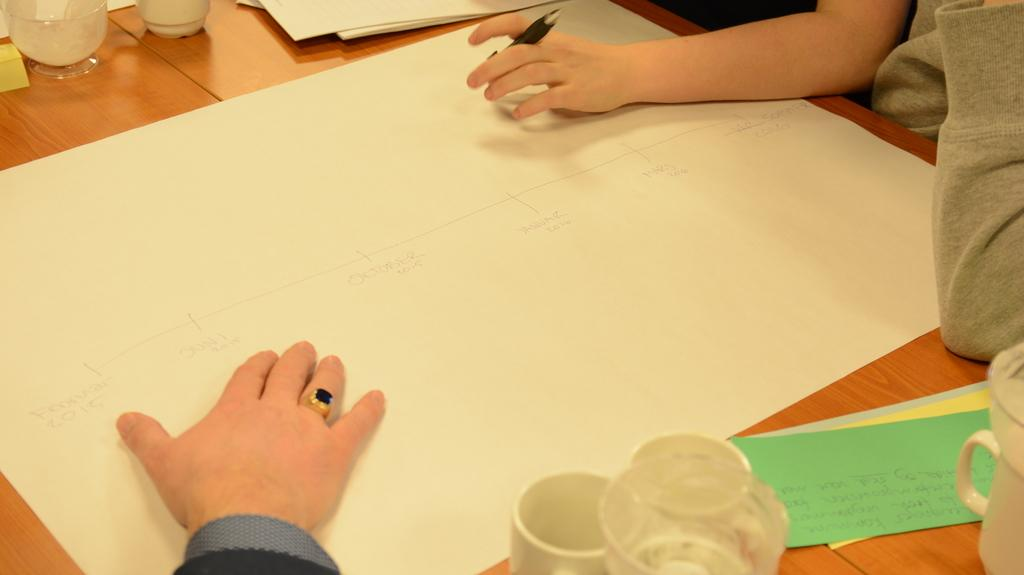What is the person holding in the image? The person is holding a pen in the image. What can be seen on the table in the image? There is a cup, a glass, and color papers on the table in the image. What is the color of the sheet in the image? The sheet is white in the image. How many people are present in the image? There are two people in the image. Are the two people in the image brothers? There is no information provided about the relationship between the two people in the image, so we cannot determine if they are brothers. 